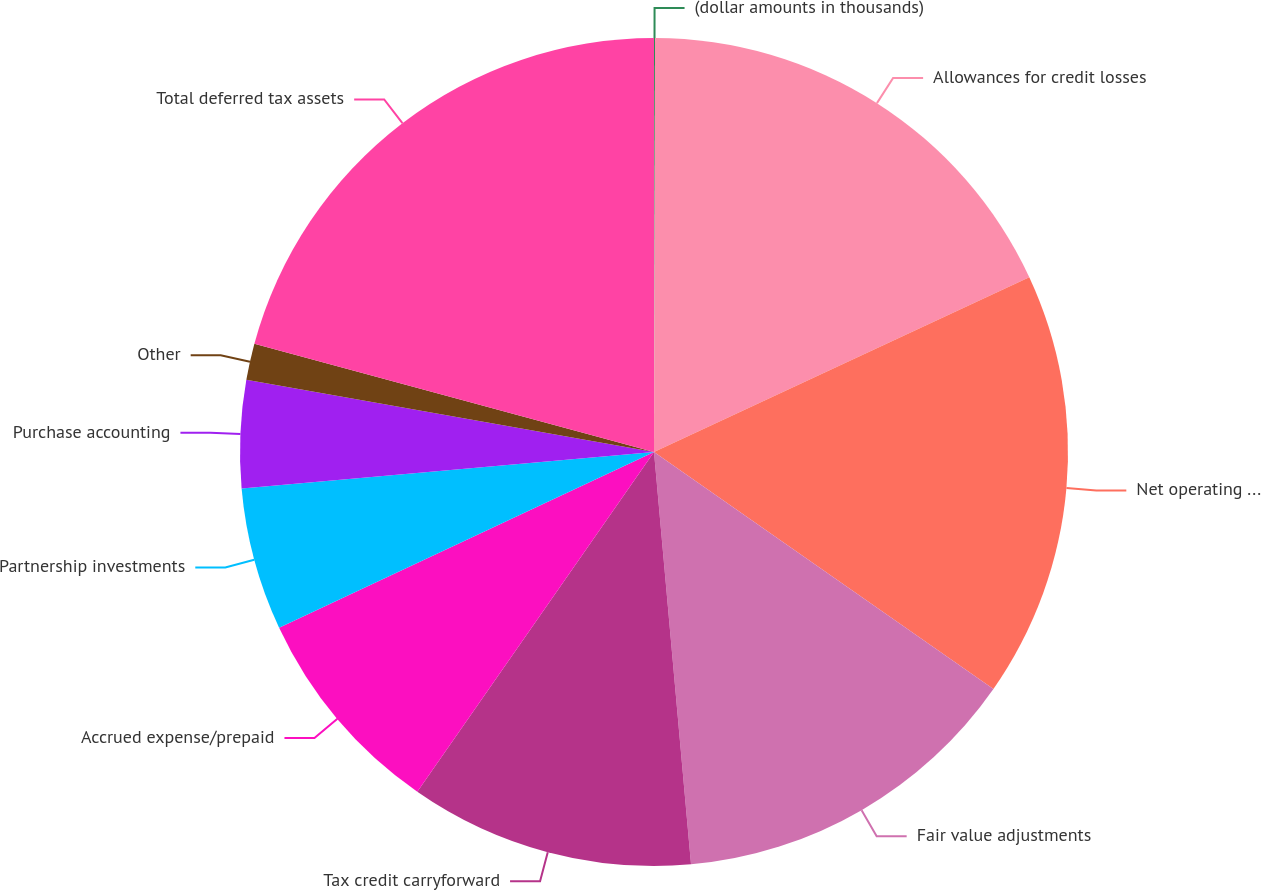Convert chart. <chart><loc_0><loc_0><loc_500><loc_500><pie_chart><fcel>(dollar amounts in thousands)<fcel>Allowances for credit losses<fcel>Net operating and other loss<fcel>Fair value adjustments<fcel>Tax credit carryforward<fcel>Accrued expense/prepaid<fcel>Partnership investments<fcel>Purchase accounting<fcel>Other<fcel>Total deferred tax assets<nl><fcel>0.04%<fcel>18.02%<fcel>16.64%<fcel>13.87%<fcel>11.11%<fcel>8.34%<fcel>5.57%<fcel>4.19%<fcel>1.42%<fcel>20.79%<nl></chart> 